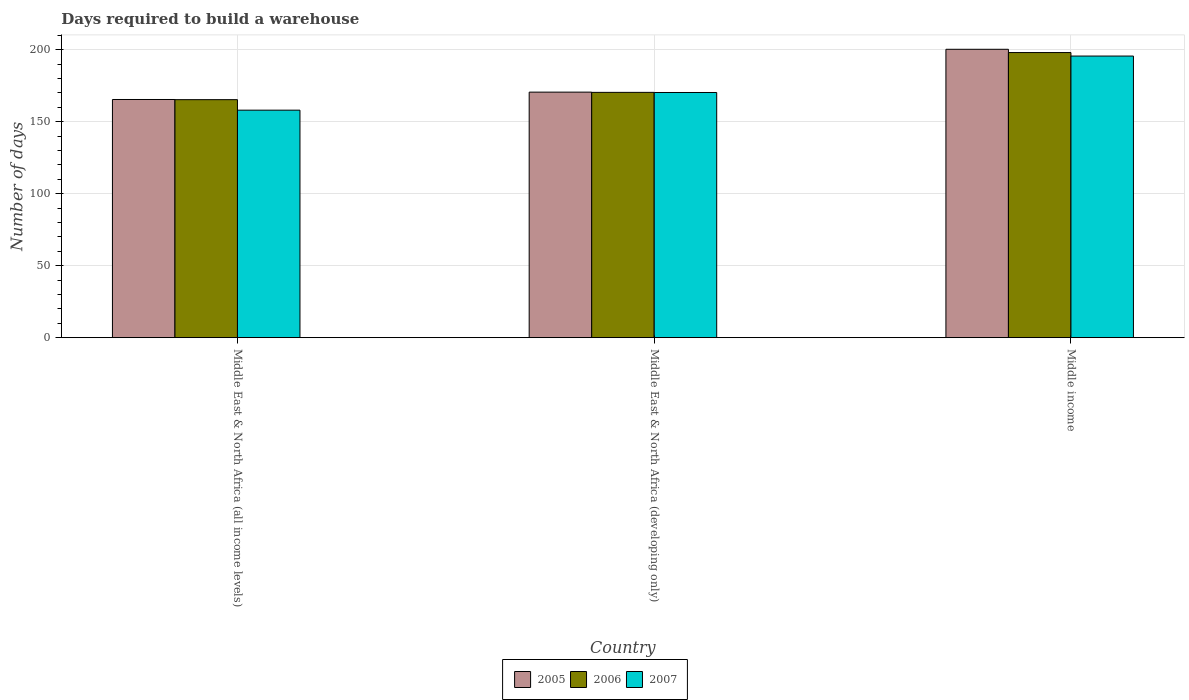How many different coloured bars are there?
Ensure brevity in your answer.  3. How many bars are there on the 2nd tick from the left?
Make the answer very short. 3. What is the label of the 1st group of bars from the left?
Offer a terse response. Middle East & North Africa (all income levels). What is the days required to build a warehouse in in 2007 in Middle East & North Africa (developing only)?
Give a very brief answer. 170.33. Across all countries, what is the maximum days required to build a warehouse in in 2005?
Your answer should be very brief. 200.35. Across all countries, what is the minimum days required to build a warehouse in in 2006?
Keep it short and to the point. 165.35. In which country was the days required to build a warehouse in in 2005 minimum?
Your response must be concise. Middle East & North Africa (all income levels). What is the total days required to build a warehouse in in 2006 in the graph?
Ensure brevity in your answer.  533.85. What is the difference between the days required to build a warehouse in in 2005 in Middle East & North Africa (all income levels) and that in Middle income?
Offer a very short reply. -34.88. What is the difference between the days required to build a warehouse in in 2006 in Middle income and the days required to build a warehouse in in 2007 in Middle East & North Africa (all income levels)?
Your answer should be very brief. 40.03. What is the average days required to build a warehouse in in 2007 per country?
Provide a succinct answer. 174.68. What is the difference between the days required to build a warehouse in of/in 2005 and days required to build a warehouse in of/in 2006 in Middle East & North Africa (developing only)?
Make the answer very short. 0.17. In how many countries, is the days required to build a warehouse in in 2006 greater than 50 days?
Give a very brief answer. 3. What is the ratio of the days required to build a warehouse in in 2007 in Middle East & North Africa (developing only) to that in Middle income?
Keep it short and to the point. 0.87. Is the days required to build a warehouse in in 2005 in Middle East & North Africa (developing only) less than that in Middle income?
Your answer should be compact. Yes. What is the difference between the highest and the second highest days required to build a warehouse in in 2007?
Offer a very short reply. -25.31. What is the difference between the highest and the lowest days required to build a warehouse in in 2007?
Make the answer very short. 37.59. Is the sum of the days required to build a warehouse in in 2007 in Middle East & North Africa (developing only) and Middle income greater than the maximum days required to build a warehouse in in 2006 across all countries?
Keep it short and to the point. Yes. What does the 1st bar from the left in Middle East & North Africa (all income levels) represents?
Provide a short and direct response. 2005. What does the 1st bar from the right in Middle East & North Africa (all income levels) represents?
Keep it short and to the point. 2007. Are all the bars in the graph horizontal?
Offer a very short reply. No. What is the difference between two consecutive major ticks on the Y-axis?
Provide a succinct answer. 50. Are the values on the major ticks of Y-axis written in scientific E-notation?
Ensure brevity in your answer.  No. Where does the legend appear in the graph?
Make the answer very short. Bottom center. How are the legend labels stacked?
Your answer should be compact. Horizontal. What is the title of the graph?
Give a very brief answer. Days required to build a warehouse. Does "1968" appear as one of the legend labels in the graph?
Make the answer very short. No. What is the label or title of the Y-axis?
Offer a terse response. Number of days. What is the Number of days of 2005 in Middle East & North Africa (all income levels)?
Give a very brief answer. 165.47. What is the Number of days in 2006 in Middle East & North Africa (all income levels)?
Ensure brevity in your answer.  165.35. What is the Number of days of 2007 in Middle East & North Africa (all income levels)?
Give a very brief answer. 158.05. What is the Number of days in 2005 in Middle East & North Africa (developing only)?
Offer a very short reply. 170.58. What is the Number of days in 2006 in Middle East & North Africa (developing only)?
Ensure brevity in your answer.  170.42. What is the Number of days in 2007 in Middle East & North Africa (developing only)?
Ensure brevity in your answer.  170.33. What is the Number of days of 2005 in Middle income?
Offer a very short reply. 200.35. What is the Number of days in 2006 in Middle income?
Your response must be concise. 198.08. What is the Number of days in 2007 in Middle income?
Ensure brevity in your answer.  195.65. Across all countries, what is the maximum Number of days in 2005?
Ensure brevity in your answer.  200.35. Across all countries, what is the maximum Number of days of 2006?
Your response must be concise. 198.08. Across all countries, what is the maximum Number of days of 2007?
Offer a very short reply. 195.65. Across all countries, what is the minimum Number of days of 2005?
Make the answer very short. 165.47. Across all countries, what is the minimum Number of days of 2006?
Your response must be concise. 165.35. Across all countries, what is the minimum Number of days of 2007?
Provide a succinct answer. 158.05. What is the total Number of days in 2005 in the graph?
Your response must be concise. 536.4. What is the total Number of days of 2006 in the graph?
Your answer should be compact. 533.85. What is the total Number of days in 2007 in the graph?
Your answer should be very brief. 524.03. What is the difference between the Number of days in 2005 in Middle East & North Africa (all income levels) and that in Middle East & North Africa (developing only)?
Your answer should be very brief. -5.11. What is the difference between the Number of days in 2006 in Middle East & North Africa (all income levels) and that in Middle East & North Africa (developing only)?
Your response must be concise. -5.06. What is the difference between the Number of days in 2007 in Middle East & North Africa (all income levels) and that in Middle East & North Africa (developing only)?
Ensure brevity in your answer.  -12.28. What is the difference between the Number of days of 2005 in Middle East & North Africa (all income levels) and that in Middle income?
Make the answer very short. -34.88. What is the difference between the Number of days in 2006 in Middle East & North Africa (all income levels) and that in Middle income?
Give a very brief answer. -32.73. What is the difference between the Number of days in 2007 in Middle East & North Africa (all income levels) and that in Middle income?
Your answer should be compact. -37.59. What is the difference between the Number of days of 2005 in Middle East & North Africa (developing only) and that in Middle income?
Provide a succinct answer. -29.76. What is the difference between the Number of days in 2006 in Middle East & North Africa (developing only) and that in Middle income?
Ensure brevity in your answer.  -27.67. What is the difference between the Number of days of 2007 in Middle East & North Africa (developing only) and that in Middle income?
Make the answer very short. -25.31. What is the difference between the Number of days in 2005 in Middle East & North Africa (all income levels) and the Number of days in 2006 in Middle East & North Africa (developing only)?
Ensure brevity in your answer.  -4.95. What is the difference between the Number of days in 2005 in Middle East & North Africa (all income levels) and the Number of days in 2007 in Middle East & North Africa (developing only)?
Keep it short and to the point. -4.86. What is the difference between the Number of days in 2006 in Middle East & North Africa (all income levels) and the Number of days in 2007 in Middle East & North Africa (developing only)?
Your answer should be compact. -4.98. What is the difference between the Number of days of 2005 in Middle East & North Africa (all income levels) and the Number of days of 2006 in Middle income?
Make the answer very short. -32.61. What is the difference between the Number of days of 2005 in Middle East & North Africa (all income levels) and the Number of days of 2007 in Middle income?
Make the answer very short. -30.18. What is the difference between the Number of days of 2006 in Middle East & North Africa (all income levels) and the Number of days of 2007 in Middle income?
Offer a very short reply. -30.29. What is the difference between the Number of days of 2005 in Middle East & North Africa (developing only) and the Number of days of 2006 in Middle income?
Your answer should be very brief. -27.5. What is the difference between the Number of days in 2005 in Middle East & North Africa (developing only) and the Number of days in 2007 in Middle income?
Provide a succinct answer. -25.06. What is the difference between the Number of days in 2006 in Middle East & North Africa (developing only) and the Number of days in 2007 in Middle income?
Ensure brevity in your answer.  -25.23. What is the average Number of days of 2005 per country?
Offer a terse response. 178.8. What is the average Number of days of 2006 per country?
Provide a succinct answer. 177.95. What is the average Number of days of 2007 per country?
Offer a terse response. 174.68. What is the difference between the Number of days in 2005 and Number of days in 2006 in Middle East & North Africa (all income levels)?
Your answer should be compact. 0.12. What is the difference between the Number of days of 2005 and Number of days of 2007 in Middle East & North Africa (all income levels)?
Offer a very short reply. 7.42. What is the difference between the Number of days of 2006 and Number of days of 2007 in Middle East & North Africa (all income levels)?
Offer a very short reply. 7.3. What is the difference between the Number of days in 2006 and Number of days in 2007 in Middle East & North Africa (developing only)?
Your answer should be very brief. 0.08. What is the difference between the Number of days of 2005 and Number of days of 2006 in Middle income?
Keep it short and to the point. 2.26. What is the difference between the Number of days of 2005 and Number of days of 2007 in Middle income?
Ensure brevity in your answer.  4.7. What is the difference between the Number of days in 2006 and Number of days in 2007 in Middle income?
Keep it short and to the point. 2.44. What is the ratio of the Number of days in 2006 in Middle East & North Africa (all income levels) to that in Middle East & North Africa (developing only)?
Give a very brief answer. 0.97. What is the ratio of the Number of days of 2007 in Middle East & North Africa (all income levels) to that in Middle East & North Africa (developing only)?
Your answer should be very brief. 0.93. What is the ratio of the Number of days of 2005 in Middle East & North Africa (all income levels) to that in Middle income?
Provide a succinct answer. 0.83. What is the ratio of the Number of days in 2006 in Middle East & North Africa (all income levels) to that in Middle income?
Provide a short and direct response. 0.83. What is the ratio of the Number of days of 2007 in Middle East & North Africa (all income levels) to that in Middle income?
Offer a terse response. 0.81. What is the ratio of the Number of days in 2005 in Middle East & North Africa (developing only) to that in Middle income?
Your answer should be very brief. 0.85. What is the ratio of the Number of days of 2006 in Middle East & North Africa (developing only) to that in Middle income?
Your answer should be compact. 0.86. What is the ratio of the Number of days in 2007 in Middle East & North Africa (developing only) to that in Middle income?
Offer a terse response. 0.87. What is the difference between the highest and the second highest Number of days in 2005?
Make the answer very short. 29.76. What is the difference between the highest and the second highest Number of days of 2006?
Keep it short and to the point. 27.67. What is the difference between the highest and the second highest Number of days of 2007?
Provide a short and direct response. 25.31. What is the difference between the highest and the lowest Number of days in 2005?
Provide a succinct answer. 34.88. What is the difference between the highest and the lowest Number of days of 2006?
Make the answer very short. 32.73. What is the difference between the highest and the lowest Number of days of 2007?
Provide a succinct answer. 37.59. 